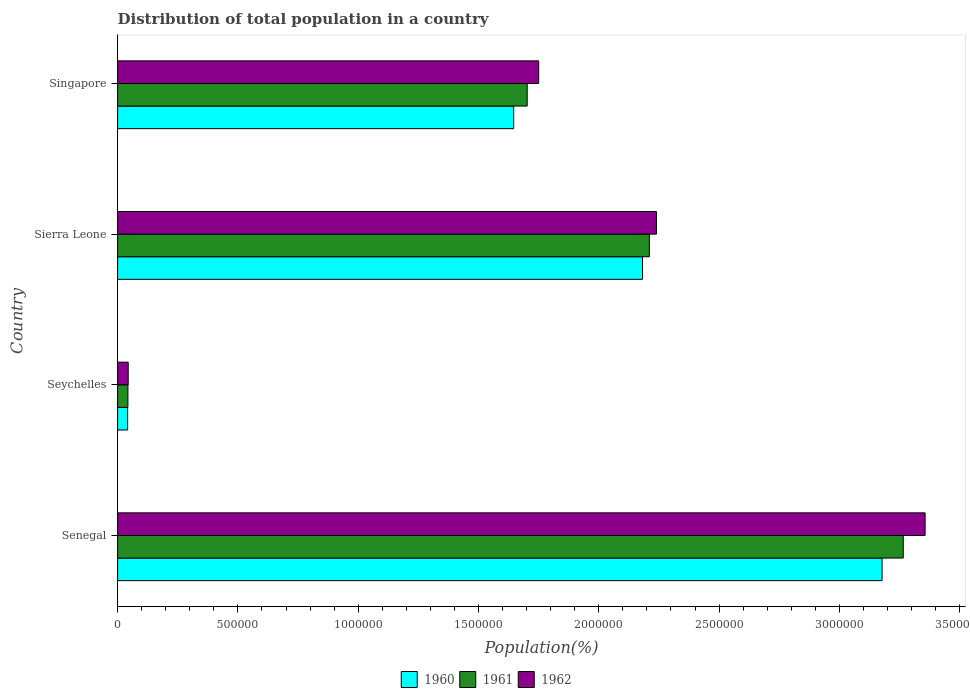Are the number of bars per tick equal to the number of legend labels?
Offer a very short reply. Yes. How many bars are there on the 1st tick from the bottom?
Provide a short and direct response. 3. What is the label of the 1st group of bars from the top?
Ensure brevity in your answer.  Singapore. What is the population of in 1961 in Singapore?
Offer a terse response. 1.70e+06. Across all countries, what is the maximum population of in 1962?
Provide a short and direct response. 3.36e+06. Across all countries, what is the minimum population of in 1960?
Your answer should be compact. 4.17e+04. In which country was the population of in 1960 maximum?
Make the answer very short. Senegal. In which country was the population of in 1960 minimum?
Your answer should be compact. Seychelles. What is the total population of in 1960 in the graph?
Offer a terse response. 7.05e+06. What is the difference between the population of in 1960 in Sierra Leone and that in Singapore?
Offer a terse response. 5.35e+05. What is the difference between the population of in 1962 in Sierra Leone and the population of in 1961 in Singapore?
Ensure brevity in your answer.  5.37e+05. What is the average population of in 1961 per country?
Offer a terse response. 1.81e+06. What is the difference between the population of in 1960 and population of in 1962 in Sierra Leone?
Make the answer very short. -5.79e+04. In how many countries, is the population of in 1962 greater than 100000 %?
Your response must be concise. 3. What is the ratio of the population of in 1960 in Seychelles to that in Singapore?
Ensure brevity in your answer.  0.03. What is the difference between the highest and the second highest population of in 1962?
Offer a terse response. 1.12e+06. What is the difference between the highest and the lowest population of in 1961?
Keep it short and to the point. 3.22e+06. What does the 3rd bar from the bottom in Seychelles represents?
Your answer should be very brief. 1962. How many bars are there?
Ensure brevity in your answer.  12. Are all the bars in the graph horizontal?
Provide a short and direct response. Yes. How many countries are there in the graph?
Your answer should be compact. 4. Does the graph contain any zero values?
Provide a short and direct response. No. Does the graph contain grids?
Make the answer very short. No. Where does the legend appear in the graph?
Make the answer very short. Bottom center. How are the legend labels stacked?
Offer a terse response. Horizontal. What is the title of the graph?
Provide a short and direct response. Distribution of total population in a country. Does "1984" appear as one of the legend labels in the graph?
Make the answer very short. No. What is the label or title of the X-axis?
Keep it short and to the point. Population(%). What is the label or title of the Y-axis?
Your response must be concise. Country. What is the Population(%) in 1960 in Senegal?
Make the answer very short. 3.18e+06. What is the Population(%) of 1961 in Senegal?
Keep it short and to the point. 3.27e+06. What is the Population(%) in 1962 in Senegal?
Offer a very short reply. 3.36e+06. What is the Population(%) of 1960 in Seychelles?
Offer a terse response. 4.17e+04. What is the Population(%) of 1961 in Seychelles?
Your answer should be very brief. 4.29e+04. What is the Population(%) of 1962 in Seychelles?
Your answer should be compact. 4.40e+04. What is the Population(%) in 1960 in Sierra Leone?
Your answer should be compact. 2.18e+06. What is the Population(%) in 1961 in Sierra Leone?
Provide a short and direct response. 2.21e+06. What is the Population(%) of 1962 in Sierra Leone?
Give a very brief answer. 2.24e+06. What is the Population(%) of 1960 in Singapore?
Provide a succinct answer. 1.65e+06. What is the Population(%) in 1961 in Singapore?
Your response must be concise. 1.70e+06. What is the Population(%) of 1962 in Singapore?
Your answer should be compact. 1.75e+06. Across all countries, what is the maximum Population(%) in 1960?
Provide a succinct answer. 3.18e+06. Across all countries, what is the maximum Population(%) of 1961?
Provide a short and direct response. 3.27e+06. Across all countries, what is the maximum Population(%) of 1962?
Your response must be concise. 3.36e+06. Across all countries, what is the minimum Population(%) of 1960?
Offer a very short reply. 4.17e+04. Across all countries, what is the minimum Population(%) in 1961?
Offer a very short reply. 4.29e+04. Across all countries, what is the minimum Population(%) of 1962?
Your response must be concise. 4.40e+04. What is the total Population(%) of 1960 in the graph?
Ensure brevity in your answer.  7.05e+06. What is the total Population(%) in 1961 in the graph?
Provide a short and direct response. 7.22e+06. What is the total Population(%) in 1962 in the graph?
Offer a very short reply. 7.39e+06. What is the difference between the Population(%) in 1960 in Senegal and that in Seychelles?
Your response must be concise. 3.14e+06. What is the difference between the Population(%) of 1961 in Senegal and that in Seychelles?
Your response must be concise. 3.22e+06. What is the difference between the Population(%) of 1962 in Senegal and that in Seychelles?
Your answer should be compact. 3.31e+06. What is the difference between the Population(%) of 1960 in Senegal and that in Sierra Leone?
Offer a terse response. 9.96e+05. What is the difference between the Population(%) of 1961 in Senegal and that in Sierra Leone?
Make the answer very short. 1.06e+06. What is the difference between the Population(%) of 1962 in Senegal and that in Sierra Leone?
Your response must be concise. 1.12e+06. What is the difference between the Population(%) in 1960 in Senegal and that in Singapore?
Your response must be concise. 1.53e+06. What is the difference between the Population(%) in 1961 in Senegal and that in Singapore?
Your response must be concise. 1.56e+06. What is the difference between the Population(%) of 1962 in Senegal and that in Singapore?
Provide a short and direct response. 1.61e+06. What is the difference between the Population(%) of 1960 in Seychelles and that in Sierra Leone?
Give a very brief answer. -2.14e+06. What is the difference between the Population(%) in 1961 in Seychelles and that in Sierra Leone?
Your answer should be very brief. -2.17e+06. What is the difference between the Population(%) in 1962 in Seychelles and that in Sierra Leone?
Keep it short and to the point. -2.20e+06. What is the difference between the Population(%) of 1960 in Seychelles and that in Singapore?
Ensure brevity in your answer.  -1.60e+06. What is the difference between the Population(%) in 1961 in Seychelles and that in Singapore?
Provide a succinct answer. -1.66e+06. What is the difference between the Population(%) in 1962 in Seychelles and that in Singapore?
Your response must be concise. -1.71e+06. What is the difference between the Population(%) of 1960 in Sierra Leone and that in Singapore?
Offer a very short reply. 5.35e+05. What is the difference between the Population(%) of 1961 in Sierra Leone and that in Singapore?
Provide a short and direct response. 5.08e+05. What is the difference between the Population(%) in 1962 in Sierra Leone and that in Singapore?
Ensure brevity in your answer.  4.89e+05. What is the difference between the Population(%) in 1960 in Senegal and the Population(%) in 1961 in Seychelles?
Your answer should be very brief. 3.13e+06. What is the difference between the Population(%) in 1960 in Senegal and the Population(%) in 1962 in Seychelles?
Ensure brevity in your answer.  3.13e+06. What is the difference between the Population(%) of 1961 in Senegal and the Population(%) of 1962 in Seychelles?
Make the answer very short. 3.22e+06. What is the difference between the Population(%) in 1960 in Senegal and the Population(%) in 1961 in Sierra Leone?
Offer a terse response. 9.67e+05. What is the difference between the Population(%) in 1960 in Senegal and the Population(%) in 1962 in Sierra Leone?
Your answer should be very brief. 9.38e+05. What is the difference between the Population(%) in 1961 in Senegal and the Population(%) in 1962 in Sierra Leone?
Keep it short and to the point. 1.03e+06. What is the difference between the Population(%) in 1960 in Senegal and the Population(%) in 1961 in Singapore?
Your response must be concise. 1.48e+06. What is the difference between the Population(%) in 1960 in Senegal and the Population(%) in 1962 in Singapore?
Your answer should be very brief. 1.43e+06. What is the difference between the Population(%) in 1961 in Senegal and the Population(%) in 1962 in Singapore?
Offer a terse response. 1.52e+06. What is the difference between the Population(%) in 1960 in Seychelles and the Population(%) in 1961 in Sierra Leone?
Your answer should be very brief. -2.17e+06. What is the difference between the Population(%) in 1960 in Seychelles and the Population(%) in 1962 in Sierra Leone?
Your response must be concise. -2.20e+06. What is the difference between the Population(%) of 1961 in Seychelles and the Population(%) of 1962 in Sierra Leone?
Your response must be concise. -2.20e+06. What is the difference between the Population(%) of 1960 in Seychelles and the Population(%) of 1961 in Singapore?
Give a very brief answer. -1.66e+06. What is the difference between the Population(%) in 1960 in Seychelles and the Population(%) in 1962 in Singapore?
Make the answer very short. -1.71e+06. What is the difference between the Population(%) of 1961 in Seychelles and the Population(%) of 1962 in Singapore?
Provide a short and direct response. -1.71e+06. What is the difference between the Population(%) in 1960 in Sierra Leone and the Population(%) in 1961 in Singapore?
Your response must be concise. 4.79e+05. What is the difference between the Population(%) of 1960 in Sierra Leone and the Population(%) of 1962 in Singapore?
Provide a succinct answer. 4.32e+05. What is the difference between the Population(%) of 1961 in Sierra Leone and the Population(%) of 1962 in Singapore?
Give a very brief answer. 4.60e+05. What is the average Population(%) of 1960 per country?
Provide a short and direct response. 1.76e+06. What is the average Population(%) of 1961 per country?
Provide a short and direct response. 1.81e+06. What is the average Population(%) in 1962 per country?
Your answer should be compact. 1.85e+06. What is the difference between the Population(%) in 1960 and Population(%) in 1961 in Senegal?
Your answer should be compact. -8.80e+04. What is the difference between the Population(%) of 1960 and Population(%) of 1962 in Senegal?
Give a very brief answer. -1.79e+05. What is the difference between the Population(%) in 1961 and Population(%) in 1962 in Senegal?
Your answer should be very brief. -9.09e+04. What is the difference between the Population(%) of 1960 and Population(%) of 1961 in Seychelles?
Provide a succinct answer. -1189. What is the difference between the Population(%) in 1960 and Population(%) in 1962 in Seychelles?
Keep it short and to the point. -2342. What is the difference between the Population(%) of 1961 and Population(%) of 1962 in Seychelles?
Keep it short and to the point. -1153. What is the difference between the Population(%) of 1960 and Population(%) of 1961 in Sierra Leone?
Your response must be concise. -2.85e+04. What is the difference between the Population(%) in 1960 and Population(%) in 1962 in Sierra Leone?
Offer a very short reply. -5.79e+04. What is the difference between the Population(%) in 1961 and Population(%) in 1962 in Sierra Leone?
Keep it short and to the point. -2.94e+04. What is the difference between the Population(%) of 1960 and Population(%) of 1961 in Singapore?
Offer a terse response. -5.60e+04. What is the difference between the Population(%) of 1960 and Population(%) of 1962 in Singapore?
Offer a very short reply. -1.04e+05. What is the difference between the Population(%) of 1961 and Population(%) of 1962 in Singapore?
Give a very brief answer. -4.78e+04. What is the ratio of the Population(%) in 1960 in Senegal to that in Seychelles?
Make the answer very short. 76.2. What is the ratio of the Population(%) of 1961 in Senegal to that in Seychelles?
Provide a succinct answer. 76.14. What is the ratio of the Population(%) in 1962 in Senegal to that in Seychelles?
Give a very brief answer. 76.21. What is the ratio of the Population(%) of 1960 in Senegal to that in Sierra Leone?
Your answer should be very brief. 1.46. What is the ratio of the Population(%) in 1961 in Senegal to that in Sierra Leone?
Give a very brief answer. 1.48. What is the ratio of the Population(%) of 1962 in Senegal to that in Sierra Leone?
Your answer should be very brief. 1.5. What is the ratio of the Population(%) of 1960 in Senegal to that in Singapore?
Offer a terse response. 1.93. What is the ratio of the Population(%) of 1961 in Senegal to that in Singapore?
Provide a short and direct response. 1.92. What is the ratio of the Population(%) of 1962 in Senegal to that in Singapore?
Your answer should be very brief. 1.92. What is the ratio of the Population(%) of 1960 in Seychelles to that in Sierra Leone?
Your response must be concise. 0.02. What is the ratio of the Population(%) of 1961 in Seychelles to that in Sierra Leone?
Offer a very short reply. 0.02. What is the ratio of the Population(%) in 1962 in Seychelles to that in Sierra Leone?
Keep it short and to the point. 0.02. What is the ratio of the Population(%) of 1960 in Seychelles to that in Singapore?
Provide a short and direct response. 0.03. What is the ratio of the Population(%) of 1961 in Seychelles to that in Singapore?
Your response must be concise. 0.03. What is the ratio of the Population(%) of 1962 in Seychelles to that in Singapore?
Your answer should be very brief. 0.03. What is the ratio of the Population(%) in 1960 in Sierra Leone to that in Singapore?
Keep it short and to the point. 1.33. What is the ratio of the Population(%) of 1961 in Sierra Leone to that in Singapore?
Offer a terse response. 1.3. What is the ratio of the Population(%) of 1962 in Sierra Leone to that in Singapore?
Offer a terse response. 1.28. What is the difference between the highest and the second highest Population(%) of 1960?
Provide a short and direct response. 9.96e+05. What is the difference between the highest and the second highest Population(%) in 1961?
Your answer should be very brief. 1.06e+06. What is the difference between the highest and the second highest Population(%) in 1962?
Offer a terse response. 1.12e+06. What is the difference between the highest and the lowest Population(%) in 1960?
Offer a very short reply. 3.14e+06. What is the difference between the highest and the lowest Population(%) of 1961?
Ensure brevity in your answer.  3.22e+06. What is the difference between the highest and the lowest Population(%) of 1962?
Ensure brevity in your answer.  3.31e+06. 